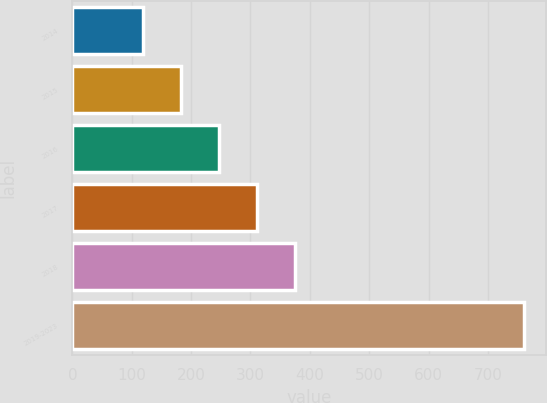<chart> <loc_0><loc_0><loc_500><loc_500><bar_chart><fcel>2014<fcel>2015<fcel>2016<fcel>2017<fcel>2018<fcel>2019-2023<nl><fcel>119<fcel>183.1<fcel>247.2<fcel>311.3<fcel>375.4<fcel>760<nl></chart> 